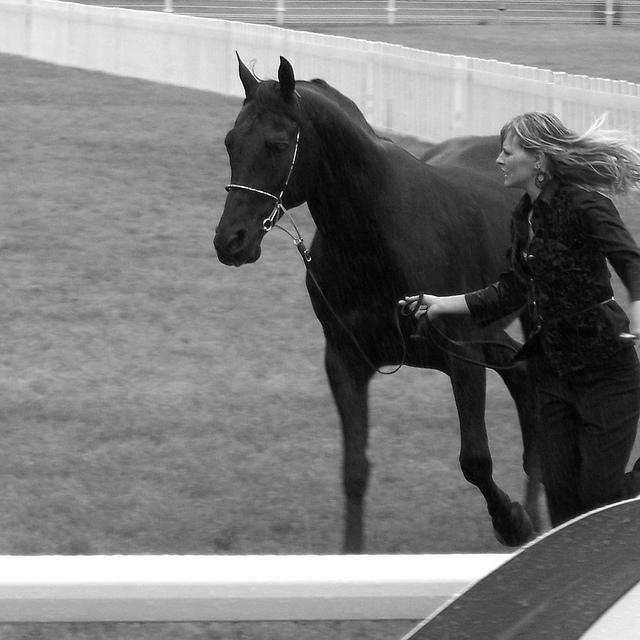Is the horse one color?
Concise answer only. Yes. Is this a show horse?
Answer briefly. Yes. How many horses?
Concise answer only. 1. Is there slack in the lead rope?
Concise answer only. Yes. Could the woman be the horse's owner?
Short answer required. Yes. 